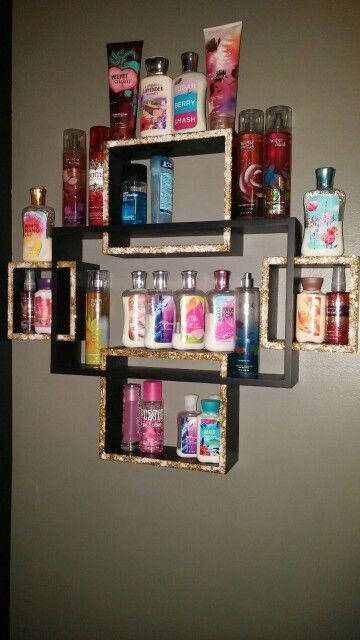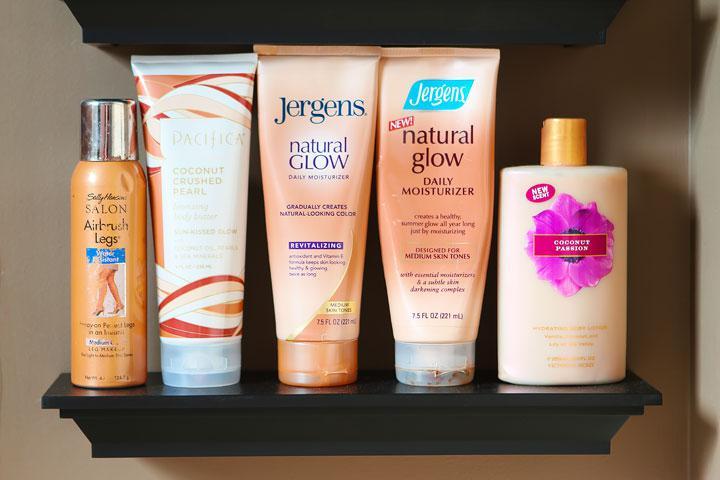The first image is the image on the left, the second image is the image on the right. Considering the images on both sides, is "An image shows one black shelf holding a row of six beauty products." valid? Answer yes or no. No. 